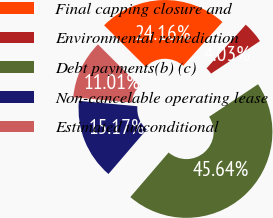<chart> <loc_0><loc_0><loc_500><loc_500><pie_chart><fcel>Final capping closure and<fcel>Environmental remediation<fcel>Debt payments(b) (c)<fcel>Non-cancelable operating lease<fcel>Estimated unconditional<nl><fcel>24.16%<fcel>4.03%<fcel>45.64%<fcel>15.17%<fcel>11.01%<nl></chart> 